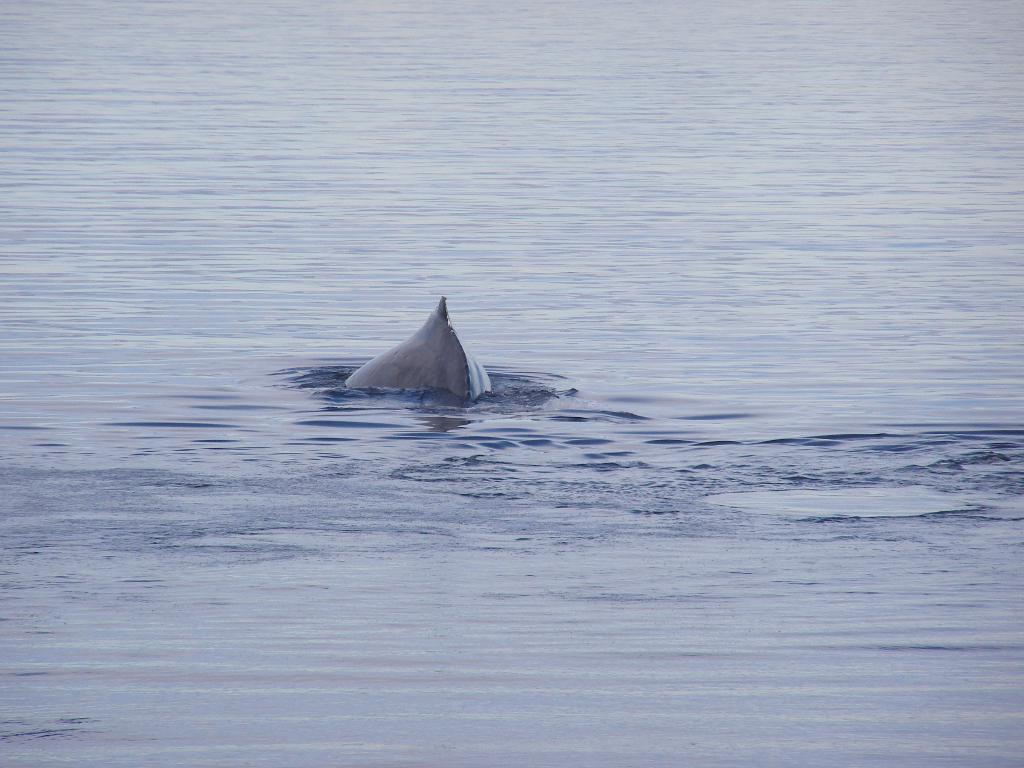Could you give a brief overview of what you see in this image? In the middle of this image I can see a fish in the water. 